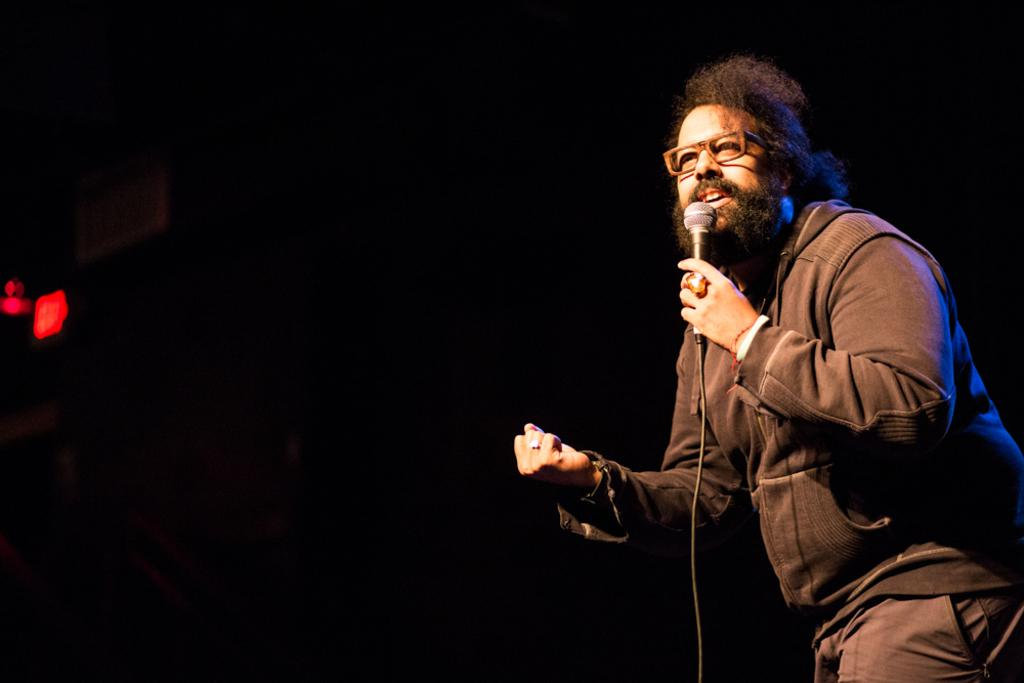What is the man in the image doing? The man is singing a song. What is the man holding while singing? The man is holding a microphone. Can you describe the man's clothing in the image? The man is wearing a jerkin, trousers, and spectacles. What is the color of the small light in the background? The small light in the background is red. How would you describe the lighting in the image? The background of the image is dark. What type of veil is draped over the group in the image? There is no group or veil present in the image; it features a man singing with a microphone. 